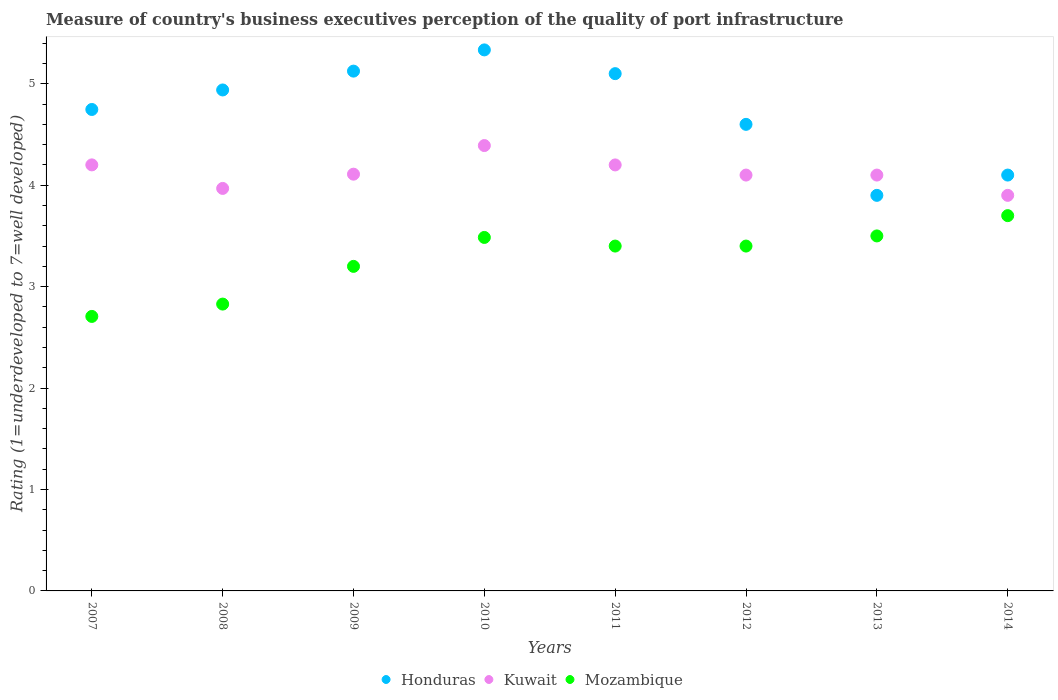How many different coloured dotlines are there?
Your answer should be very brief. 3. What is the ratings of the quality of port infrastructure in Honduras in 2010?
Your response must be concise. 5.33. Across all years, what is the minimum ratings of the quality of port infrastructure in Kuwait?
Ensure brevity in your answer.  3.9. In which year was the ratings of the quality of port infrastructure in Mozambique minimum?
Your answer should be compact. 2007. What is the total ratings of the quality of port infrastructure in Mozambique in the graph?
Give a very brief answer. 26.22. What is the difference between the ratings of the quality of port infrastructure in Kuwait in 2008 and that in 2014?
Make the answer very short. 0.07. What is the difference between the ratings of the quality of port infrastructure in Kuwait in 2009 and the ratings of the quality of port infrastructure in Mozambique in 2007?
Your answer should be very brief. 1.4. What is the average ratings of the quality of port infrastructure in Kuwait per year?
Provide a short and direct response. 4.12. In the year 2008, what is the difference between the ratings of the quality of port infrastructure in Kuwait and ratings of the quality of port infrastructure in Honduras?
Offer a terse response. -0.97. What is the ratio of the ratings of the quality of port infrastructure in Kuwait in 2008 to that in 2014?
Your response must be concise. 1.02. Is the difference between the ratings of the quality of port infrastructure in Kuwait in 2013 and 2014 greater than the difference between the ratings of the quality of port infrastructure in Honduras in 2013 and 2014?
Your answer should be compact. Yes. What is the difference between the highest and the second highest ratings of the quality of port infrastructure in Mozambique?
Provide a short and direct response. 0.2. What is the difference between the highest and the lowest ratings of the quality of port infrastructure in Mozambique?
Offer a terse response. 0.99. Is the sum of the ratings of the quality of port infrastructure in Mozambique in 2011 and 2013 greater than the maximum ratings of the quality of port infrastructure in Kuwait across all years?
Keep it short and to the point. Yes. Does the ratings of the quality of port infrastructure in Mozambique monotonically increase over the years?
Provide a succinct answer. No. Is the ratings of the quality of port infrastructure in Kuwait strictly less than the ratings of the quality of port infrastructure in Honduras over the years?
Make the answer very short. No. How many years are there in the graph?
Keep it short and to the point. 8. Does the graph contain any zero values?
Give a very brief answer. No. Does the graph contain grids?
Offer a terse response. No. What is the title of the graph?
Offer a very short reply. Measure of country's business executives perception of the quality of port infrastructure. What is the label or title of the Y-axis?
Your answer should be very brief. Rating (1=underdeveloped to 7=well developed). What is the Rating (1=underdeveloped to 7=well developed) in Honduras in 2007?
Your response must be concise. 4.75. What is the Rating (1=underdeveloped to 7=well developed) of Kuwait in 2007?
Ensure brevity in your answer.  4.2. What is the Rating (1=underdeveloped to 7=well developed) of Mozambique in 2007?
Provide a succinct answer. 2.71. What is the Rating (1=underdeveloped to 7=well developed) in Honduras in 2008?
Ensure brevity in your answer.  4.94. What is the Rating (1=underdeveloped to 7=well developed) of Kuwait in 2008?
Provide a short and direct response. 3.97. What is the Rating (1=underdeveloped to 7=well developed) of Mozambique in 2008?
Your answer should be compact. 2.83. What is the Rating (1=underdeveloped to 7=well developed) of Honduras in 2009?
Make the answer very short. 5.12. What is the Rating (1=underdeveloped to 7=well developed) of Kuwait in 2009?
Make the answer very short. 4.11. What is the Rating (1=underdeveloped to 7=well developed) of Mozambique in 2009?
Make the answer very short. 3.2. What is the Rating (1=underdeveloped to 7=well developed) in Honduras in 2010?
Your answer should be very brief. 5.33. What is the Rating (1=underdeveloped to 7=well developed) in Kuwait in 2010?
Your answer should be very brief. 4.39. What is the Rating (1=underdeveloped to 7=well developed) of Mozambique in 2010?
Make the answer very short. 3.49. What is the Rating (1=underdeveloped to 7=well developed) of Honduras in 2012?
Your answer should be compact. 4.6. What is the Rating (1=underdeveloped to 7=well developed) of Kuwait in 2012?
Ensure brevity in your answer.  4.1. What is the Rating (1=underdeveloped to 7=well developed) in Mozambique in 2012?
Give a very brief answer. 3.4. What is the Rating (1=underdeveloped to 7=well developed) in Honduras in 2013?
Give a very brief answer. 3.9. What is the Rating (1=underdeveloped to 7=well developed) in Kuwait in 2013?
Provide a succinct answer. 4.1. What is the Rating (1=underdeveloped to 7=well developed) of Mozambique in 2014?
Provide a short and direct response. 3.7. Across all years, what is the maximum Rating (1=underdeveloped to 7=well developed) of Honduras?
Offer a terse response. 5.33. Across all years, what is the maximum Rating (1=underdeveloped to 7=well developed) of Kuwait?
Your response must be concise. 4.39. Across all years, what is the minimum Rating (1=underdeveloped to 7=well developed) of Mozambique?
Provide a short and direct response. 2.71. What is the total Rating (1=underdeveloped to 7=well developed) of Honduras in the graph?
Provide a succinct answer. 37.84. What is the total Rating (1=underdeveloped to 7=well developed) in Kuwait in the graph?
Offer a terse response. 32.97. What is the total Rating (1=underdeveloped to 7=well developed) in Mozambique in the graph?
Your answer should be very brief. 26.22. What is the difference between the Rating (1=underdeveloped to 7=well developed) of Honduras in 2007 and that in 2008?
Your answer should be very brief. -0.19. What is the difference between the Rating (1=underdeveloped to 7=well developed) in Kuwait in 2007 and that in 2008?
Give a very brief answer. 0.23. What is the difference between the Rating (1=underdeveloped to 7=well developed) in Mozambique in 2007 and that in 2008?
Your answer should be compact. -0.12. What is the difference between the Rating (1=underdeveloped to 7=well developed) of Honduras in 2007 and that in 2009?
Ensure brevity in your answer.  -0.38. What is the difference between the Rating (1=underdeveloped to 7=well developed) of Kuwait in 2007 and that in 2009?
Offer a very short reply. 0.09. What is the difference between the Rating (1=underdeveloped to 7=well developed) in Mozambique in 2007 and that in 2009?
Offer a very short reply. -0.49. What is the difference between the Rating (1=underdeveloped to 7=well developed) of Honduras in 2007 and that in 2010?
Offer a terse response. -0.59. What is the difference between the Rating (1=underdeveloped to 7=well developed) of Kuwait in 2007 and that in 2010?
Your answer should be compact. -0.19. What is the difference between the Rating (1=underdeveloped to 7=well developed) of Mozambique in 2007 and that in 2010?
Give a very brief answer. -0.78. What is the difference between the Rating (1=underdeveloped to 7=well developed) in Honduras in 2007 and that in 2011?
Ensure brevity in your answer.  -0.35. What is the difference between the Rating (1=underdeveloped to 7=well developed) of Kuwait in 2007 and that in 2011?
Your response must be concise. 0. What is the difference between the Rating (1=underdeveloped to 7=well developed) in Mozambique in 2007 and that in 2011?
Offer a terse response. -0.69. What is the difference between the Rating (1=underdeveloped to 7=well developed) of Honduras in 2007 and that in 2012?
Your response must be concise. 0.15. What is the difference between the Rating (1=underdeveloped to 7=well developed) in Kuwait in 2007 and that in 2012?
Offer a very short reply. 0.1. What is the difference between the Rating (1=underdeveloped to 7=well developed) in Mozambique in 2007 and that in 2012?
Give a very brief answer. -0.69. What is the difference between the Rating (1=underdeveloped to 7=well developed) in Honduras in 2007 and that in 2013?
Your answer should be compact. 0.85. What is the difference between the Rating (1=underdeveloped to 7=well developed) in Kuwait in 2007 and that in 2013?
Offer a terse response. 0.1. What is the difference between the Rating (1=underdeveloped to 7=well developed) in Mozambique in 2007 and that in 2013?
Provide a short and direct response. -0.79. What is the difference between the Rating (1=underdeveloped to 7=well developed) of Honduras in 2007 and that in 2014?
Provide a short and direct response. 0.65. What is the difference between the Rating (1=underdeveloped to 7=well developed) of Kuwait in 2007 and that in 2014?
Keep it short and to the point. 0.3. What is the difference between the Rating (1=underdeveloped to 7=well developed) in Mozambique in 2007 and that in 2014?
Ensure brevity in your answer.  -0.99. What is the difference between the Rating (1=underdeveloped to 7=well developed) of Honduras in 2008 and that in 2009?
Your answer should be very brief. -0.19. What is the difference between the Rating (1=underdeveloped to 7=well developed) in Kuwait in 2008 and that in 2009?
Provide a succinct answer. -0.14. What is the difference between the Rating (1=underdeveloped to 7=well developed) in Mozambique in 2008 and that in 2009?
Ensure brevity in your answer.  -0.37. What is the difference between the Rating (1=underdeveloped to 7=well developed) of Honduras in 2008 and that in 2010?
Your answer should be compact. -0.39. What is the difference between the Rating (1=underdeveloped to 7=well developed) of Kuwait in 2008 and that in 2010?
Make the answer very short. -0.42. What is the difference between the Rating (1=underdeveloped to 7=well developed) of Mozambique in 2008 and that in 2010?
Your answer should be compact. -0.66. What is the difference between the Rating (1=underdeveloped to 7=well developed) in Honduras in 2008 and that in 2011?
Provide a short and direct response. -0.16. What is the difference between the Rating (1=underdeveloped to 7=well developed) of Kuwait in 2008 and that in 2011?
Offer a very short reply. -0.23. What is the difference between the Rating (1=underdeveloped to 7=well developed) in Mozambique in 2008 and that in 2011?
Provide a succinct answer. -0.57. What is the difference between the Rating (1=underdeveloped to 7=well developed) of Honduras in 2008 and that in 2012?
Ensure brevity in your answer.  0.34. What is the difference between the Rating (1=underdeveloped to 7=well developed) of Kuwait in 2008 and that in 2012?
Your response must be concise. -0.13. What is the difference between the Rating (1=underdeveloped to 7=well developed) of Mozambique in 2008 and that in 2012?
Ensure brevity in your answer.  -0.57. What is the difference between the Rating (1=underdeveloped to 7=well developed) in Honduras in 2008 and that in 2013?
Keep it short and to the point. 1.04. What is the difference between the Rating (1=underdeveloped to 7=well developed) of Kuwait in 2008 and that in 2013?
Provide a succinct answer. -0.13. What is the difference between the Rating (1=underdeveloped to 7=well developed) in Mozambique in 2008 and that in 2013?
Provide a succinct answer. -0.67. What is the difference between the Rating (1=underdeveloped to 7=well developed) in Honduras in 2008 and that in 2014?
Make the answer very short. 0.84. What is the difference between the Rating (1=underdeveloped to 7=well developed) in Kuwait in 2008 and that in 2014?
Provide a succinct answer. 0.07. What is the difference between the Rating (1=underdeveloped to 7=well developed) of Mozambique in 2008 and that in 2014?
Provide a succinct answer. -0.87. What is the difference between the Rating (1=underdeveloped to 7=well developed) in Honduras in 2009 and that in 2010?
Offer a terse response. -0.21. What is the difference between the Rating (1=underdeveloped to 7=well developed) in Kuwait in 2009 and that in 2010?
Give a very brief answer. -0.28. What is the difference between the Rating (1=underdeveloped to 7=well developed) in Mozambique in 2009 and that in 2010?
Make the answer very short. -0.29. What is the difference between the Rating (1=underdeveloped to 7=well developed) of Honduras in 2009 and that in 2011?
Keep it short and to the point. 0.02. What is the difference between the Rating (1=underdeveloped to 7=well developed) of Kuwait in 2009 and that in 2011?
Your answer should be compact. -0.09. What is the difference between the Rating (1=underdeveloped to 7=well developed) of Mozambique in 2009 and that in 2011?
Ensure brevity in your answer.  -0.2. What is the difference between the Rating (1=underdeveloped to 7=well developed) of Honduras in 2009 and that in 2012?
Your response must be concise. 0.52. What is the difference between the Rating (1=underdeveloped to 7=well developed) in Kuwait in 2009 and that in 2012?
Offer a very short reply. 0.01. What is the difference between the Rating (1=underdeveloped to 7=well developed) in Mozambique in 2009 and that in 2012?
Provide a succinct answer. -0.2. What is the difference between the Rating (1=underdeveloped to 7=well developed) in Honduras in 2009 and that in 2013?
Offer a terse response. 1.22. What is the difference between the Rating (1=underdeveloped to 7=well developed) in Kuwait in 2009 and that in 2013?
Your answer should be compact. 0.01. What is the difference between the Rating (1=underdeveloped to 7=well developed) in Mozambique in 2009 and that in 2013?
Offer a terse response. -0.3. What is the difference between the Rating (1=underdeveloped to 7=well developed) in Honduras in 2009 and that in 2014?
Make the answer very short. 1.02. What is the difference between the Rating (1=underdeveloped to 7=well developed) of Kuwait in 2009 and that in 2014?
Your answer should be very brief. 0.21. What is the difference between the Rating (1=underdeveloped to 7=well developed) in Mozambique in 2009 and that in 2014?
Give a very brief answer. -0.5. What is the difference between the Rating (1=underdeveloped to 7=well developed) of Honduras in 2010 and that in 2011?
Offer a terse response. 0.23. What is the difference between the Rating (1=underdeveloped to 7=well developed) of Kuwait in 2010 and that in 2011?
Make the answer very short. 0.19. What is the difference between the Rating (1=underdeveloped to 7=well developed) in Mozambique in 2010 and that in 2011?
Your response must be concise. 0.09. What is the difference between the Rating (1=underdeveloped to 7=well developed) of Honduras in 2010 and that in 2012?
Your answer should be very brief. 0.73. What is the difference between the Rating (1=underdeveloped to 7=well developed) in Kuwait in 2010 and that in 2012?
Your answer should be very brief. 0.29. What is the difference between the Rating (1=underdeveloped to 7=well developed) of Mozambique in 2010 and that in 2012?
Ensure brevity in your answer.  0.09. What is the difference between the Rating (1=underdeveloped to 7=well developed) of Honduras in 2010 and that in 2013?
Your response must be concise. 1.43. What is the difference between the Rating (1=underdeveloped to 7=well developed) in Kuwait in 2010 and that in 2013?
Your answer should be compact. 0.29. What is the difference between the Rating (1=underdeveloped to 7=well developed) in Mozambique in 2010 and that in 2013?
Your answer should be compact. -0.01. What is the difference between the Rating (1=underdeveloped to 7=well developed) of Honduras in 2010 and that in 2014?
Your answer should be compact. 1.23. What is the difference between the Rating (1=underdeveloped to 7=well developed) in Kuwait in 2010 and that in 2014?
Give a very brief answer. 0.49. What is the difference between the Rating (1=underdeveloped to 7=well developed) of Mozambique in 2010 and that in 2014?
Provide a succinct answer. -0.21. What is the difference between the Rating (1=underdeveloped to 7=well developed) in Honduras in 2011 and that in 2012?
Offer a terse response. 0.5. What is the difference between the Rating (1=underdeveloped to 7=well developed) in Kuwait in 2011 and that in 2012?
Offer a terse response. 0.1. What is the difference between the Rating (1=underdeveloped to 7=well developed) of Mozambique in 2011 and that in 2013?
Your response must be concise. -0.1. What is the difference between the Rating (1=underdeveloped to 7=well developed) in Honduras in 2011 and that in 2014?
Make the answer very short. 1. What is the difference between the Rating (1=underdeveloped to 7=well developed) in Mozambique in 2012 and that in 2013?
Offer a very short reply. -0.1. What is the difference between the Rating (1=underdeveloped to 7=well developed) of Honduras in 2012 and that in 2014?
Your answer should be compact. 0.5. What is the difference between the Rating (1=underdeveloped to 7=well developed) of Mozambique in 2012 and that in 2014?
Give a very brief answer. -0.3. What is the difference between the Rating (1=underdeveloped to 7=well developed) of Honduras in 2013 and that in 2014?
Provide a succinct answer. -0.2. What is the difference between the Rating (1=underdeveloped to 7=well developed) in Kuwait in 2013 and that in 2014?
Offer a very short reply. 0.2. What is the difference between the Rating (1=underdeveloped to 7=well developed) in Mozambique in 2013 and that in 2014?
Your response must be concise. -0.2. What is the difference between the Rating (1=underdeveloped to 7=well developed) of Honduras in 2007 and the Rating (1=underdeveloped to 7=well developed) of Kuwait in 2008?
Provide a short and direct response. 0.78. What is the difference between the Rating (1=underdeveloped to 7=well developed) in Honduras in 2007 and the Rating (1=underdeveloped to 7=well developed) in Mozambique in 2008?
Provide a short and direct response. 1.92. What is the difference between the Rating (1=underdeveloped to 7=well developed) of Kuwait in 2007 and the Rating (1=underdeveloped to 7=well developed) of Mozambique in 2008?
Keep it short and to the point. 1.37. What is the difference between the Rating (1=underdeveloped to 7=well developed) in Honduras in 2007 and the Rating (1=underdeveloped to 7=well developed) in Kuwait in 2009?
Your answer should be very brief. 0.64. What is the difference between the Rating (1=underdeveloped to 7=well developed) of Honduras in 2007 and the Rating (1=underdeveloped to 7=well developed) of Mozambique in 2009?
Provide a succinct answer. 1.55. What is the difference between the Rating (1=underdeveloped to 7=well developed) of Honduras in 2007 and the Rating (1=underdeveloped to 7=well developed) of Kuwait in 2010?
Offer a terse response. 0.36. What is the difference between the Rating (1=underdeveloped to 7=well developed) in Honduras in 2007 and the Rating (1=underdeveloped to 7=well developed) in Mozambique in 2010?
Make the answer very short. 1.26. What is the difference between the Rating (1=underdeveloped to 7=well developed) in Kuwait in 2007 and the Rating (1=underdeveloped to 7=well developed) in Mozambique in 2010?
Provide a succinct answer. 0.72. What is the difference between the Rating (1=underdeveloped to 7=well developed) in Honduras in 2007 and the Rating (1=underdeveloped to 7=well developed) in Kuwait in 2011?
Your response must be concise. 0.55. What is the difference between the Rating (1=underdeveloped to 7=well developed) in Honduras in 2007 and the Rating (1=underdeveloped to 7=well developed) in Mozambique in 2011?
Your answer should be compact. 1.35. What is the difference between the Rating (1=underdeveloped to 7=well developed) of Kuwait in 2007 and the Rating (1=underdeveloped to 7=well developed) of Mozambique in 2011?
Offer a very short reply. 0.8. What is the difference between the Rating (1=underdeveloped to 7=well developed) of Honduras in 2007 and the Rating (1=underdeveloped to 7=well developed) of Kuwait in 2012?
Keep it short and to the point. 0.65. What is the difference between the Rating (1=underdeveloped to 7=well developed) of Honduras in 2007 and the Rating (1=underdeveloped to 7=well developed) of Mozambique in 2012?
Ensure brevity in your answer.  1.35. What is the difference between the Rating (1=underdeveloped to 7=well developed) of Kuwait in 2007 and the Rating (1=underdeveloped to 7=well developed) of Mozambique in 2012?
Your answer should be compact. 0.8. What is the difference between the Rating (1=underdeveloped to 7=well developed) of Honduras in 2007 and the Rating (1=underdeveloped to 7=well developed) of Kuwait in 2013?
Offer a terse response. 0.65. What is the difference between the Rating (1=underdeveloped to 7=well developed) in Honduras in 2007 and the Rating (1=underdeveloped to 7=well developed) in Mozambique in 2013?
Your answer should be compact. 1.25. What is the difference between the Rating (1=underdeveloped to 7=well developed) of Kuwait in 2007 and the Rating (1=underdeveloped to 7=well developed) of Mozambique in 2013?
Provide a short and direct response. 0.7. What is the difference between the Rating (1=underdeveloped to 7=well developed) in Honduras in 2007 and the Rating (1=underdeveloped to 7=well developed) in Kuwait in 2014?
Provide a short and direct response. 0.85. What is the difference between the Rating (1=underdeveloped to 7=well developed) in Honduras in 2007 and the Rating (1=underdeveloped to 7=well developed) in Mozambique in 2014?
Give a very brief answer. 1.05. What is the difference between the Rating (1=underdeveloped to 7=well developed) of Kuwait in 2007 and the Rating (1=underdeveloped to 7=well developed) of Mozambique in 2014?
Keep it short and to the point. 0.5. What is the difference between the Rating (1=underdeveloped to 7=well developed) of Honduras in 2008 and the Rating (1=underdeveloped to 7=well developed) of Kuwait in 2009?
Your response must be concise. 0.83. What is the difference between the Rating (1=underdeveloped to 7=well developed) of Honduras in 2008 and the Rating (1=underdeveloped to 7=well developed) of Mozambique in 2009?
Make the answer very short. 1.74. What is the difference between the Rating (1=underdeveloped to 7=well developed) of Kuwait in 2008 and the Rating (1=underdeveloped to 7=well developed) of Mozambique in 2009?
Your answer should be very brief. 0.77. What is the difference between the Rating (1=underdeveloped to 7=well developed) in Honduras in 2008 and the Rating (1=underdeveloped to 7=well developed) in Kuwait in 2010?
Provide a short and direct response. 0.55. What is the difference between the Rating (1=underdeveloped to 7=well developed) of Honduras in 2008 and the Rating (1=underdeveloped to 7=well developed) of Mozambique in 2010?
Offer a very short reply. 1.45. What is the difference between the Rating (1=underdeveloped to 7=well developed) in Kuwait in 2008 and the Rating (1=underdeveloped to 7=well developed) in Mozambique in 2010?
Offer a very short reply. 0.48. What is the difference between the Rating (1=underdeveloped to 7=well developed) of Honduras in 2008 and the Rating (1=underdeveloped to 7=well developed) of Kuwait in 2011?
Your response must be concise. 0.74. What is the difference between the Rating (1=underdeveloped to 7=well developed) in Honduras in 2008 and the Rating (1=underdeveloped to 7=well developed) in Mozambique in 2011?
Your response must be concise. 1.54. What is the difference between the Rating (1=underdeveloped to 7=well developed) in Kuwait in 2008 and the Rating (1=underdeveloped to 7=well developed) in Mozambique in 2011?
Provide a short and direct response. 0.57. What is the difference between the Rating (1=underdeveloped to 7=well developed) of Honduras in 2008 and the Rating (1=underdeveloped to 7=well developed) of Kuwait in 2012?
Give a very brief answer. 0.84. What is the difference between the Rating (1=underdeveloped to 7=well developed) of Honduras in 2008 and the Rating (1=underdeveloped to 7=well developed) of Mozambique in 2012?
Keep it short and to the point. 1.54. What is the difference between the Rating (1=underdeveloped to 7=well developed) of Kuwait in 2008 and the Rating (1=underdeveloped to 7=well developed) of Mozambique in 2012?
Give a very brief answer. 0.57. What is the difference between the Rating (1=underdeveloped to 7=well developed) of Honduras in 2008 and the Rating (1=underdeveloped to 7=well developed) of Kuwait in 2013?
Your response must be concise. 0.84. What is the difference between the Rating (1=underdeveloped to 7=well developed) of Honduras in 2008 and the Rating (1=underdeveloped to 7=well developed) of Mozambique in 2013?
Offer a terse response. 1.44. What is the difference between the Rating (1=underdeveloped to 7=well developed) in Kuwait in 2008 and the Rating (1=underdeveloped to 7=well developed) in Mozambique in 2013?
Keep it short and to the point. 0.47. What is the difference between the Rating (1=underdeveloped to 7=well developed) of Honduras in 2008 and the Rating (1=underdeveloped to 7=well developed) of Kuwait in 2014?
Provide a short and direct response. 1.04. What is the difference between the Rating (1=underdeveloped to 7=well developed) of Honduras in 2008 and the Rating (1=underdeveloped to 7=well developed) of Mozambique in 2014?
Make the answer very short. 1.24. What is the difference between the Rating (1=underdeveloped to 7=well developed) of Kuwait in 2008 and the Rating (1=underdeveloped to 7=well developed) of Mozambique in 2014?
Your response must be concise. 0.27. What is the difference between the Rating (1=underdeveloped to 7=well developed) in Honduras in 2009 and the Rating (1=underdeveloped to 7=well developed) in Kuwait in 2010?
Provide a succinct answer. 0.73. What is the difference between the Rating (1=underdeveloped to 7=well developed) of Honduras in 2009 and the Rating (1=underdeveloped to 7=well developed) of Mozambique in 2010?
Your response must be concise. 1.64. What is the difference between the Rating (1=underdeveloped to 7=well developed) of Kuwait in 2009 and the Rating (1=underdeveloped to 7=well developed) of Mozambique in 2010?
Provide a succinct answer. 0.62. What is the difference between the Rating (1=underdeveloped to 7=well developed) of Honduras in 2009 and the Rating (1=underdeveloped to 7=well developed) of Kuwait in 2011?
Make the answer very short. 0.92. What is the difference between the Rating (1=underdeveloped to 7=well developed) of Honduras in 2009 and the Rating (1=underdeveloped to 7=well developed) of Mozambique in 2011?
Give a very brief answer. 1.72. What is the difference between the Rating (1=underdeveloped to 7=well developed) of Kuwait in 2009 and the Rating (1=underdeveloped to 7=well developed) of Mozambique in 2011?
Offer a very short reply. 0.71. What is the difference between the Rating (1=underdeveloped to 7=well developed) in Honduras in 2009 and the Rating (1=underdeveloped to 7=well developed) in Kuwait in 2012?
Your answer should be very brief. 1.02. What is the difference between the Rating (1=underdeveloped to 7=well developed) in Honduras in 2009 and the Rating (1=underdeveloped to 7=well developed) in Mozambique in 2012?
Keep it short and to the point. 1.72. What is the difference between the Rating (1=underdeveloped to 7=well developed) in Kuwait in 2009 and the Rating (1=underdeveloped to 7=well developed) in Mozambique in 2012?
Provide a short and direct response. 0.71. What is the difference between the Rating (1=underdeveloped to 7=well developed) in Honduras in 2009 and the Rating (1=underdeveloped to 7=well developed) in Kuwait in 2013?
Offer a terse response. 1.02. What is the difference between the Rating (1=underdeveloped to 7=well developed) in Honduras in 2009 and the Rating (1=underdeveloped to 7=well developed) in Mozambique in 2013?
Keep it short and to the point. 1.62. What is the difference between the Rating (1=underdeveloped to 7=well developed) in Kuwait in 2009 and the Rating (1=underdeveloped to 7=well developed) in Mozambique in 2013?
Provide a succinct answer. 0.61. What is the difference between the Rating (1=underdeveloped to 7=well developed) of Honduras in 2009 and the Rating (1=underdeveloped to 7=well developed) of Kuwait in 2014?
Provide a succinct answer. 1.22. What is the difference between the Rating (1=underdeveloped to 7=well developed) in Honduras in 2009 and the Rating (1=underdeveloped to 7=well developed) in Mozambique in 2014?
Make the answer very short. 1.42. What is the difference between the Rating (1=underdeveloped to 7=well developed) in Kuwait in 2009 and the Rating (1=underdeveloped to 7=well developed) in Mozambique in 2014?
Offer a terse response. 0.41. What is the difference between the Rating (1=underdeveloped to 7=well developed) in Honduras in 2010 and the Rating (1=underdeveloped to 7=well developed) in Kuwait in 2011?
Provide a succinct answer. 1.13. What is the difference between the Rating (1=underdeveloped to 7=well developed) in Honduras in 2010 and the Rating (1=underdeveloped to 7=well developed) in Mozambique in 2011?
Provide a short and direct response. 1.93. What is the difference between the Rating (1=underdeveloped to 7=well developed) of Honduras in 2010 and the Rating (1=underdeveloped to 7=well developed) of Kuwait in 2012?
Provide a succinct answer. 1.23. What is the difference between the Rating (1=underdeveloped to 7=well developed) in Honduras in 2010 and the Rating (1=underdeveloped to 7=well developed) in Mozambique in 2012?
Provide a short and direct response. 1.93. What is the difference between the Rating (1=underdeveloped to 7=well developed) of Honduras in 2010 and the Rating (1=underdeveloped to 7=well developed) of Kuwait in 2013?
Offer a terse response. 1.23. What is the difference between the Rating (1=underdeveloped to 7=well developed) of Honduras in 2010 and the Rating (1=underdeveloped to 7=well developed) of Mozambique in 2013?
Your response must be concise. 1.83. What is the difference between the Rating (1=underdeveloped to 7=well developed) in Kuwait in 2010 and the Rating (1=underdeveloped to 7=well developed) in Mozambique in 2013?
Make the answer very short. 0.89. What is the difference between the Rating (1=underdeveloped to 7=well developed) of Honduras in 2010 and the Rating (1=underdeveloped to 7=well developed) of Kuwait in 2014?
Give a very brief answer. 1.43. What is the difference between the Rating (1=underdeveloped to 7=well developed) of Honduras in 2010 and the Rating (1=underdeveloped to 7=well developed) of Mozambique in 2014?
Offer a very short reply. 1.63. What is the difference between the Rating (1=underdeveloped to 7=well developed) in Kuwait in 2010 and the Rating (1=underdeveloped to 7=well developed) in Mozambique in 2014?
Provide a succinct answer. 0.69. What is the difference between the Rating (1=underdeveloped to 7=well developed) in Honduras in 2011 and the Rating (1=underdeveloped to 7=well developed) in Kuwait in 2012?
Provide a short and direct response. 1. What is the difference between the Rating (1=underdeveloped to 7=well developed) in Honduras in 2011 and the Rating (1=underdeveloped to 7=well developed) in Mozambique in 2012?
Give a very brief answer. 1.7. What is the difference between the Rating (1=underdeveloped to 7=well developed) of Honduras in 2011 and the Rating (1=underdeveloped to 7=well developed) of Mozambique in 2014?
Your answer should be very brief. 1.4. What is the difference between the Rating (1=underdeveloped to 7=well developed) of Honduras in 2012 and the Rating (1=underdeveloped to 7=well developed) of Kuwait in 2013?
Your answer should be compact. 0.5. What is the difference between the Rating (1=underdeveloped to 7=well developed) in Honduras in 2012 and the Rating (1=underdeveloped to 7=well developed) in Mozambique in 2013?
Your response must be concise. 1.1. What is the difference between the Rating (1=underdeveloped to 7=well developed) in Kuwait in 2012 and the Rating (1=underdeveloped to 7=well developed) in Mozambique in 2013?
Offer a very short reply. 0.6. What is the difference between the Rating (1=underdeveloped to 7=well developed) in Honduras in 2012 and the Rating (1=underdeveloped to 7=well developed) in Kuwait in 2014?
Offer a very short reply. 0.7. What is the difference between the Rating (1=underdeveloped to 7=well developed) in Honduras in 2012 and the Rating (1=underdeveloped to 7=well developed) in Mozambique in 2014?
Your answer should be very brief. 0.9. What is the difference between the Rating (1=underdeveloped to 7=well developed) of Honduras in 2013 and the Rating (1=underdeveloped to 7=well developed) of Mozambique in 2014?
Give a very brief answer. 0.2. What is the average Rating (1=underdeveloped to 7=well developed) of Honduras per year?
Provide a short and direct response. 4.73. What is the average Rating (1=underdeveloped to 7=well developed) of Kuwait per year?
Your answer should be compact. 4.12. What is the average Rating (1=underdeveloped to 7=well developed) in Mozambique per year?
Your answer should be compact. 3.28. In the year 2007, what is the difference between the Rating (1=underdeveloped to 7=well developed) of Honduras and Rating (1=underdeveloped to 7=well developed) of Kuwait?
Keep it short and to the point. 0.55. In the year 2007, what is the difference between the Rating (1=underdeveloped to 7=well developed) in Honduras and Rating (1=underdeveloped to 7=well developed) in Mozambique?
Your response must be concise. 2.04. In the year 2007, what is the difference between the Rating (1=underdeveloped to 7=well developed) in Kuwait and Rating (1=underdeveloped to 7=well developed) in Mozambique?
Provide a short and direct response. 1.49. In the year 2008, what is the difference between the Rating (1=underdeveloped to 7=well developed) in Honduras and Rating (1=underdeveloped to 7=well developed) in Kuwait?
Make the answer very short. 0.97. In the year 2008, what is the difference between the Rating (1=underdeveloped to 7=well developed) in Honduras and Rating (1=underdeveloped to 7=well developed) in Mozambique?
Provide a succinct answer. 2.11. In the year 2008, what is the difference between the Rating (1=underdeveloped to 7=well developed) of Kuwait and Rating (1=underdeveloped to 7=well developed) of Mozambique?
Provide a short and direct response. 1.14. In the year 2009, what is the difference between the Rating (1=underdeveloped to 7=well developed) in Honduras and Rating (1=underdeveloped to 7=well developed) in Mozambique?
Keep it short and to the point. 1.93. In the year 2010, what is the difference between the Rating (1=underdeveloped to 7=well developed) of Honduras and Rating (1=underdeveloped to 7=well developed) of Kuwait?
Provide a succinct answer. 0.94. In the year 2010, what is the difference between the Rating (1=underdeveloped to 7=well developed) of Honduras and Rating (1=underdeveloped to 7=well developed) of Mozambique?
Keep it short and to the point. 1.85. In the year 2010, what is the difference between the Rating (1=underdeveloped to 7=well developed) in Kuwait and Rating (1=underdeveloped to 7=well developed) in Mozambique?
Ensure brevity in your answer.  0.91. In the year 2012, what is the difference between the Rating (1=underdeveloped to 7=well developed) in Kuwait and Rating (1=underdeveloped to 7=well developed) in Mozambique?
Your answer should be compact. 0.7. In the year 2013, what is the difference between the Rating (1=underdeveloped to 7=well developed) of Honduras and Rating (1=underdeveloped to 7=well developed) of Mozambique?
Provide a short and direct response. 0.4. What is the ratio of the Rating (1=underdeveloped to 7=well developed) in Honduras in 2007 to that in 2008?
Your response must be concise. 0.96. What is the ratio of the Rating (1=underdeveloped to 7=well developed) in Kuwait in 2007 to that in 2008?
Your answer should be very brief. 1.06. What is the ratio of the Rating (1=underdeveloped to 7=well developed) in Mozambique in 2007 to that in 2008?
Your answer should be very brief. 0.96. What is the ratio of the Rating (1=underdeveloped to 7=well developed) in Honduras in 2007 to that in 2009?
Offer a very short reply. 0.93. What is the ratio of the Rating (1=underdeveloped to 7=well developed) in Kuwait in 2007 to that in 2009?
Keep it short and to the point. 1.02. What is the ratio of the Rating (1=underdeveloped to 7=well developed) of Mozambique in 2007 to that in 2009?
Make the answer very short. 0.85. What is the ratio of the Rating (1=underdeveloped to 7=well developed) of Honduras in 2007 to that in 2010?
Provide a short and direct response. 0.89. What is the ratio of the Rating (1=underdeveloped to 7=well developed) in Kuwait in 2007 to that in 2010?
Your response must be concise. 0.96. What is the ratio of the Rating (1=underdeveloped to 7=well developed) of Mozambique in 2007 to that in 2010?
Your answer should be compact. 0.78. What is the ratio of the Rating (1=underdeveloped to 7=well developed) of Honduras in 2007 to that in 2011?
Ensure brevity in your answer.  0.93. What is the ratio of the Rating (1=underdeveloped to 7=well developed) of Mozambique in 2007 to that in 2011?
Offer a terse response. 0.8. What is the ratio of the Rating (1=underdeveloped to 7=well developed) of Honduras in 2007 to that in 2012?
Offer a very short reply. 1.03. What is the ratio of the Rating (1=underdeveloped to 7=well developed) of Kuwait in 2007 to that in 2012?
Give a very brief answer. 1.02. What is the ratio of the Rating (1=underdeveloped to 7=well developed) in Mozambique in 2007 to that in 2012?
Your answer should be very brief. 0.8. What is the ratio of the Rating (1=underdeveloped to 7=well developed) in Honduras in 2007 to that in 2013?
Provide a short and direct response. 1.22. What is the ratio of the Rating (1=underdeveloped to 7=well developed) of Kuwait in 2007 to that in 2013?
Ensure brevity in your answer.  1.02. What is the ratio of the Rating (1=underdeveloped to 7=well developed) of Mozambique in 2007 to that in 2013?
Make the answer very short. 0.77. What is the ratio of the Rating (1=underdeveloped to 7=well developed) of Honduras in 2007 to that in 2014?
Your response must be concise. 1.16. What is the ratio of the Rating (1=underdeveloped to 7=well developed) of Kuwait in 2007 to that in 2014?
Give a very brief answer. 1.08. What is the ratio of the Rating (1=underdeveloped to 7=well developed) in Mozambique in 2007 to that in 2014?
Offer a terse response. 0.73. What is the ratio of the Rating (1=underdeveloped to 7=well developed) of Honduras in 2008 to that in 2009?
Give a very brief answer. 0.96. What is the ratio of the Rating (1=underdeveloped to 7=well developed) in Kuwait in 2008 to that in 2009?
Your answer should be very brief. 0.97. What is the ratio of the Rating (1=underdeveloped to 7=well developed) in Mozambique in 2008 to that in 2009?
Your answer should be compact. 0.88. What is the ratio of the Rating (1=underdeveloped to 7=well developed) of Honduras in 2008 to that in 2010?
Offer a terse response. 0.93. What is the ratio of the Rating (1=underdeveloped to 7=well developed) of Kuwait in 2008 to that in 2010?
Your response must be concise. 0.9. What is the ratio of the Rating (1=underdeveloped to 7=well developed) in Mozambique in 2008 to that in 2010?
Provide a succinct answer. 0.81. What is the ratio of the Rating (1=underdeveloped to 7=well developed) of Honduras in 2008 to that in 2011?
Your answer should be very brief. 0.97. What is the ratio of the Rating (1=underdeveloped to 7=well developed) of Kuwait in 2008 to that in 2011?
Provide a succinct answer. 0.94. What is the ratio of the Rating (1=underdeveloped to 7=well developed) in Mozambique in 2008 to that in 2011?
Your response must be concise. 0.83. What is the ratio of the Rating (1=underdeveloped to 7=well developed) of Honduras in 2008 to that in 2012?
Give a very brief answer. 1.07. What is the ratio of the Rating (1=underdeveloped to 7=well developed) of Kuwait in 2008 to that in 2012?
Ensure brevity in your answer.  0.97. What is the ratio of the Rating (1=underdeveloped to 7=well developed) of Mozambique in 2008 to that in 2012?
Provide a succinct answer. 0.83. What is the ratio of the Rating (1=underdeveloped to 7=well developed) of Honduras in 2008 to that in 2013?
Give a very brief answer. 1.27. What is the ratio of the Rating (1=underdeveloped to 7=well developed) in Kuwait in 2008 to that in 2013?
Offer a very short reply. 0.97. What is the ratio of the Rating (1=underdeveloped to 7=well developed) in Mozambique in 2008 to that in 2013?
Make the answer very short. 0.81. What is the ratio of the Rating (1=underdeveloped to 7=well developed) of Honduras in 2008 to that in 2014?
Make the answer very short. 1.2. What is the ratio of the Rating (1=underdeveloped to 7=well developed) in Kuwait in 2008 to that in 2014?
Offer a terse response. 1.02. What is the ratio of the Rating (1=underdeveloped to 7=well developed) in Mozambique in 2008 to that in 2014?
Keep it short and to the point. 0.76. What is the ratio of the Rating (1=underdeveloped to 7=well developed) in Honduras in 2009 to that in 2010?
Your answer should be very brief. 0.96. What is the ratio of the Rating (1=underdeveloped to 7=well developed) of Kuwait in 2009 to that in 2010?
Offer a very short reply. 0.94. What is the ratio of the Rating (1=underdeveloped to 7=well developed) of Mozambique in 2009 to that in 2010?
Your response must be concise. 0.92. What is the ratio of the Rating (1=underdeveloped to 7=well developed) of Kuwait in 2009 to that in 2011?
Keep it short and to the point. 0.98. What is the ratio of the Rating (1=underdeveloped to 7=well developed) of Mozambique in 2009 to that in 2011?
Provide a succinct answer. 0.94. What is the ratio of the Rating (1=underdeveloped to 7=well developed) in Honduras in 2009 to that in 2012?
Make the answer very short. 1.11. What is the ratio of the Rating (1=underdeveloped to 7=well developed) of Mozambique in 2009 to that in 2012?
Your answer should be compact. 0.94. What is the ratio of the Rating (1=underdeveloped to 7=well developed) of Honduras in 2009 to that in 2013?
Make the answer very short. 1.31. What is the ratio of the Rating (1=underdeveloped to 7=well developed) in Kuwait in 2009 to that in 2013?
Your response must be concise. 1. What is the ratio of the Rating (1=underdeveloped to 7=well developed) of Mozambique in 2009 to that in 2013?
Keep it short and to the point. 0.91. What is the ratio of the Rating (1=underdeveloped to 7=well developed) in Kuwait in 2009 to that in 2014?
Provide a succinct answer. 1.05. What is the ratio of the Rating (1=underdeveloped to 7=well developed) in Mozambique in 2009 to that in 2014?
Provide a succinct answer. 0.86. What is the ratio of the Rating (1=underdeveloped to 7=well developed) of Honduras in 2010 to that in 2011?
Ensure brevity in your answer.  1.05. What is the ratio of the Rating (1=underdeveloped to 7=well developed) of Kuwait in 2010 to that in 2011?
Keep it short and to the point. 1.05. What is the ratio of the Rating (1=underdeveloped to 7=well developed) in Mozambique in 2010 to that in 2011?
Your answer should be very brief. 1.02. What is the ratio of the Rating (1=underdeveloped to 7=well developed) in Honduras in 2010 to that in 2012?
Provide a succinct answer. 1.16. What is the ratio of the Rating (1=underdeveloped to 7=well developed) in Kuwait in 2010 to that in 2012?
Your response must be concise. 1.07. What is the ratio of the Rating (1=underdeveloped to 7=well developed) of Honduras in 2010 to that in 2013?
Make the answer very short. 1.37. What is the ratio of the Rating (1=underdeveloped to 7=well developed) of Kuwait in 2010 to that in 2013?
Provide a succinct answer. 1.07. What is the ratio of the Rating (1=underdeveloped to 7=well developed) of Honduras in 2010 to that in 2014?
Keep it short and to the point. 1.3. What is the ratio of the Rating (1=underdeveloped to 7=well developed) of Kuwait in 2010 to that in 2014?
Your answer should be compact. 1.13. What is the ratio of the Rating (1=underdeveloped to 7=well developed) of Mozambique in 2010 to that in 2014?
Give a very brief answer. 0.94. What is the ratio of the Rating (1=underdeveloped to 7=well developed) of Honduras in 2011 to that in 2012?
Keep it short and to the point. 1.11. What is the ratio of the Rating (1=underdeveloped to 7=well developed) of Kuwait in 2011 to that in 2012?
Offer a terse response. 1.02. What is the ratio of the Rating (1=underdeveloped to 7=well developed) in Mozambique in 2011 to that in 2012?
Give a very brief answer. 1. What is the ratio of the Rating (1=underdeveloped to 7=well developed) in Honduras in 2011 to that in 2013?
Give a very brief answer. 1.31. What is the ratio of the Rating (1=underdeveloped to 7=well developed) of Kuwait in 2011 to that in 2013?
Provide a short and direct response. 1.02. What is the ratio of the Rating (1=underdeveloped to 7=well developed) of Mozambique in 2011 to that in 2013?
Your response must be concise. 0.97. What is the ratio of the Rating (1=underdeveloped to 7=well developed) of Honduras in 2011 to that in 2014?
Your response must be concise. 1.24. What is the ratio of the Rating (1=underdeveloped to 7=well developed) of Kuwait in 2011 to that in 2014?
Keep it short and to the point. 1.08. What is the ratio of the Rating (1=underdeveloped to 7=well developed) of Mozambique in 2011 to that in 2014?
Provide a succinct answer. 0.92. What is the ratio of the Rating (1=underdeveloped to 7=well developed) of Honduras in 2012 to that in 2013?
Offer a very short reply. 1.18. What is the ratio of the Rating (1=underdeveloped to 7=well developed) of Mozambique in 2012 to that in 2013?
Give a very brief answer. 0.97. What is the ratio of the Rating (1=underdeveloped to 7=well developed) of Honduras in 2012 to that in 2014?
Provide a succinct answer. 1.12. What is the ratio of the Rating (1=underdeveloped to 7=well developed) in Kuwait in 2012 to that in 2014?
Keep it short and to the point. 1.05. What is the ratio of the Rating (1=underdeveloped to 7=well developed) of Mozambique in 2012 to that in 2014?
Give a very brief answer. 0.92. What is the ratio of the Rating (1=underdeveloped to 7=well developed) of Honduras in 2013 to that in 2014?
Provide a succinct answer. 0.95. What is the ratio of the Rating (1=underdeveloped to 7=well developed) in Kuwait in 2013 to that in 2014?
Make the answer very short. 1.05. What is the ratio of the Rating (1=underdeveloped to 7=well developed) of Mozambique in 2013 to that in 2014?
Keep it short and to the point. 0.95. What is the difference between the highest and the second highest Rating (1=underdeveloped to 7=well developed) in Honduras?
Make the answer very short. 0.21. What is the difference between the highest and the second highest Rating (1=underdeveloped to 7=well developed) in Kuwait?
Give a very brief answer. 0.19. What is the difference between the highest and the lowest Rating (1=underdeveloped to 7=well developed) of Honduras?
Your answer should be very brief. 1.43. What is the difference between the highest and the lowest Rating (1=underdeveloped to 7=well developed) in Kuwait?
Your answer should be very brief. 0.49. 